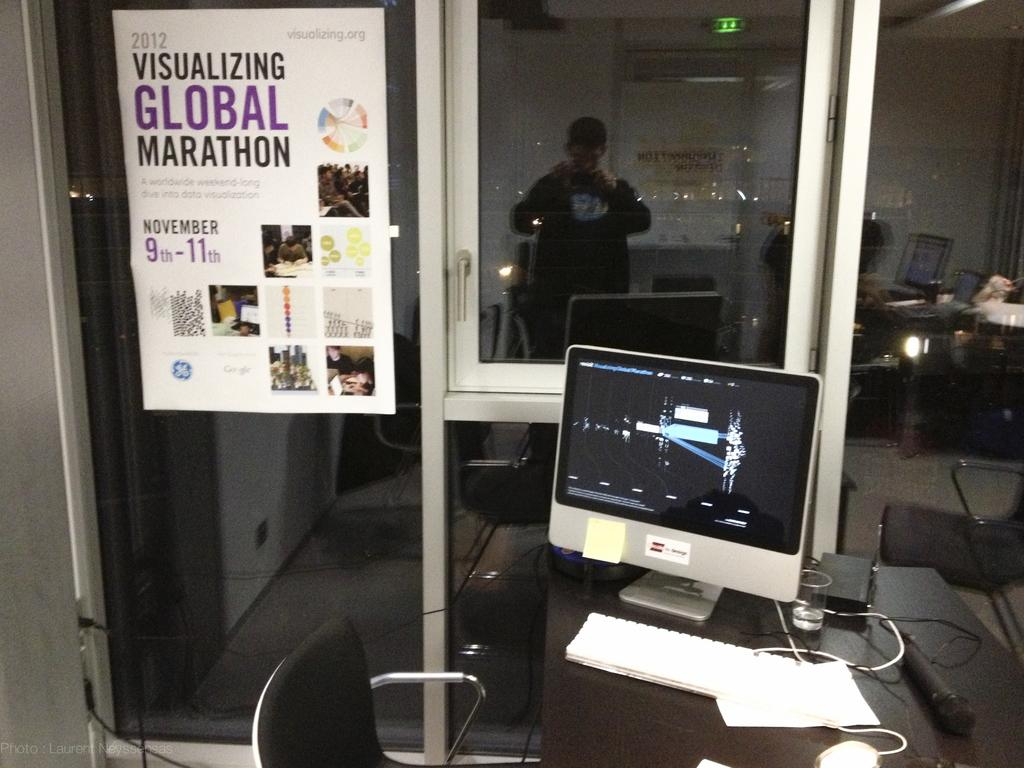What electronic device is on the table in the image? There is a computer on the table in the image. What type of furniture is in the image? There is a chair in the image. What can be seen on the wall in the image? There is a poster with text in the image. What architectural feature is visible in the image? There is a window in the image. How many loaves of bread are on the computer in the image? There are no loaves of bread present in the image, and they are not on the computer. 